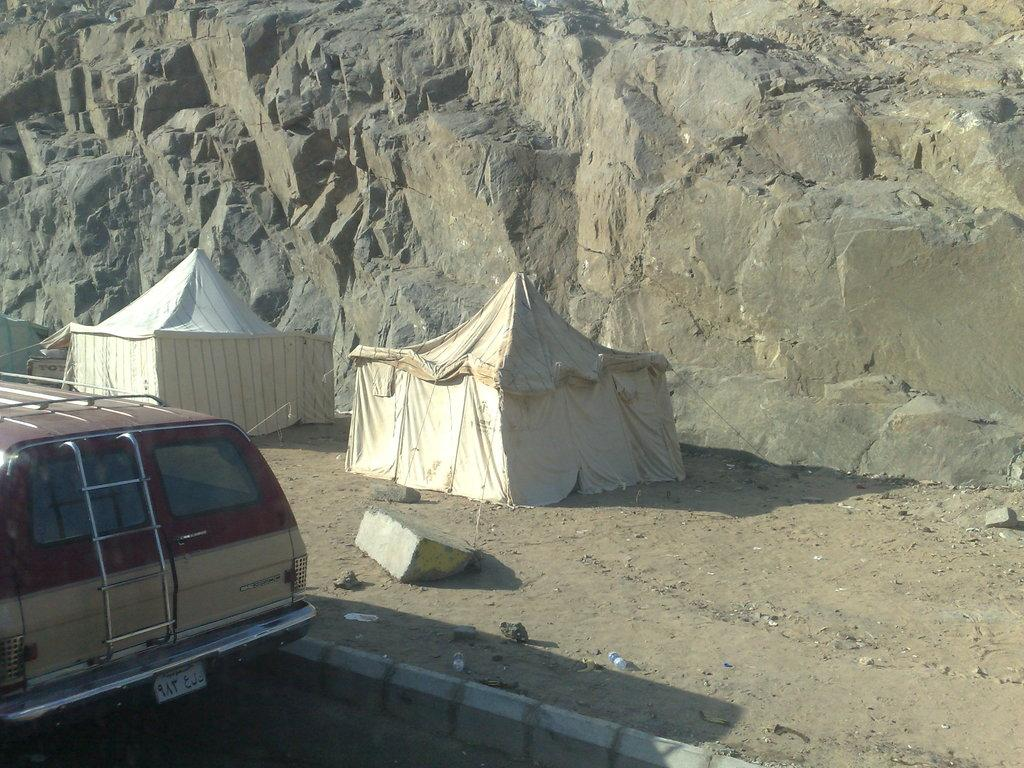How many tent houses are in the image? There are two white tent houses in the image. What is located beside the tent houses? There is a vehicle beside the tent houses in the left corner. What can be seen in the background of the image? There is a rock mountain in the background of the image. What type of action is taking place in the downtown area of the image? There is no downtown area or any action taking place in the image; it features two white tent houses, a vehicle, and a rock mountain in the background. 